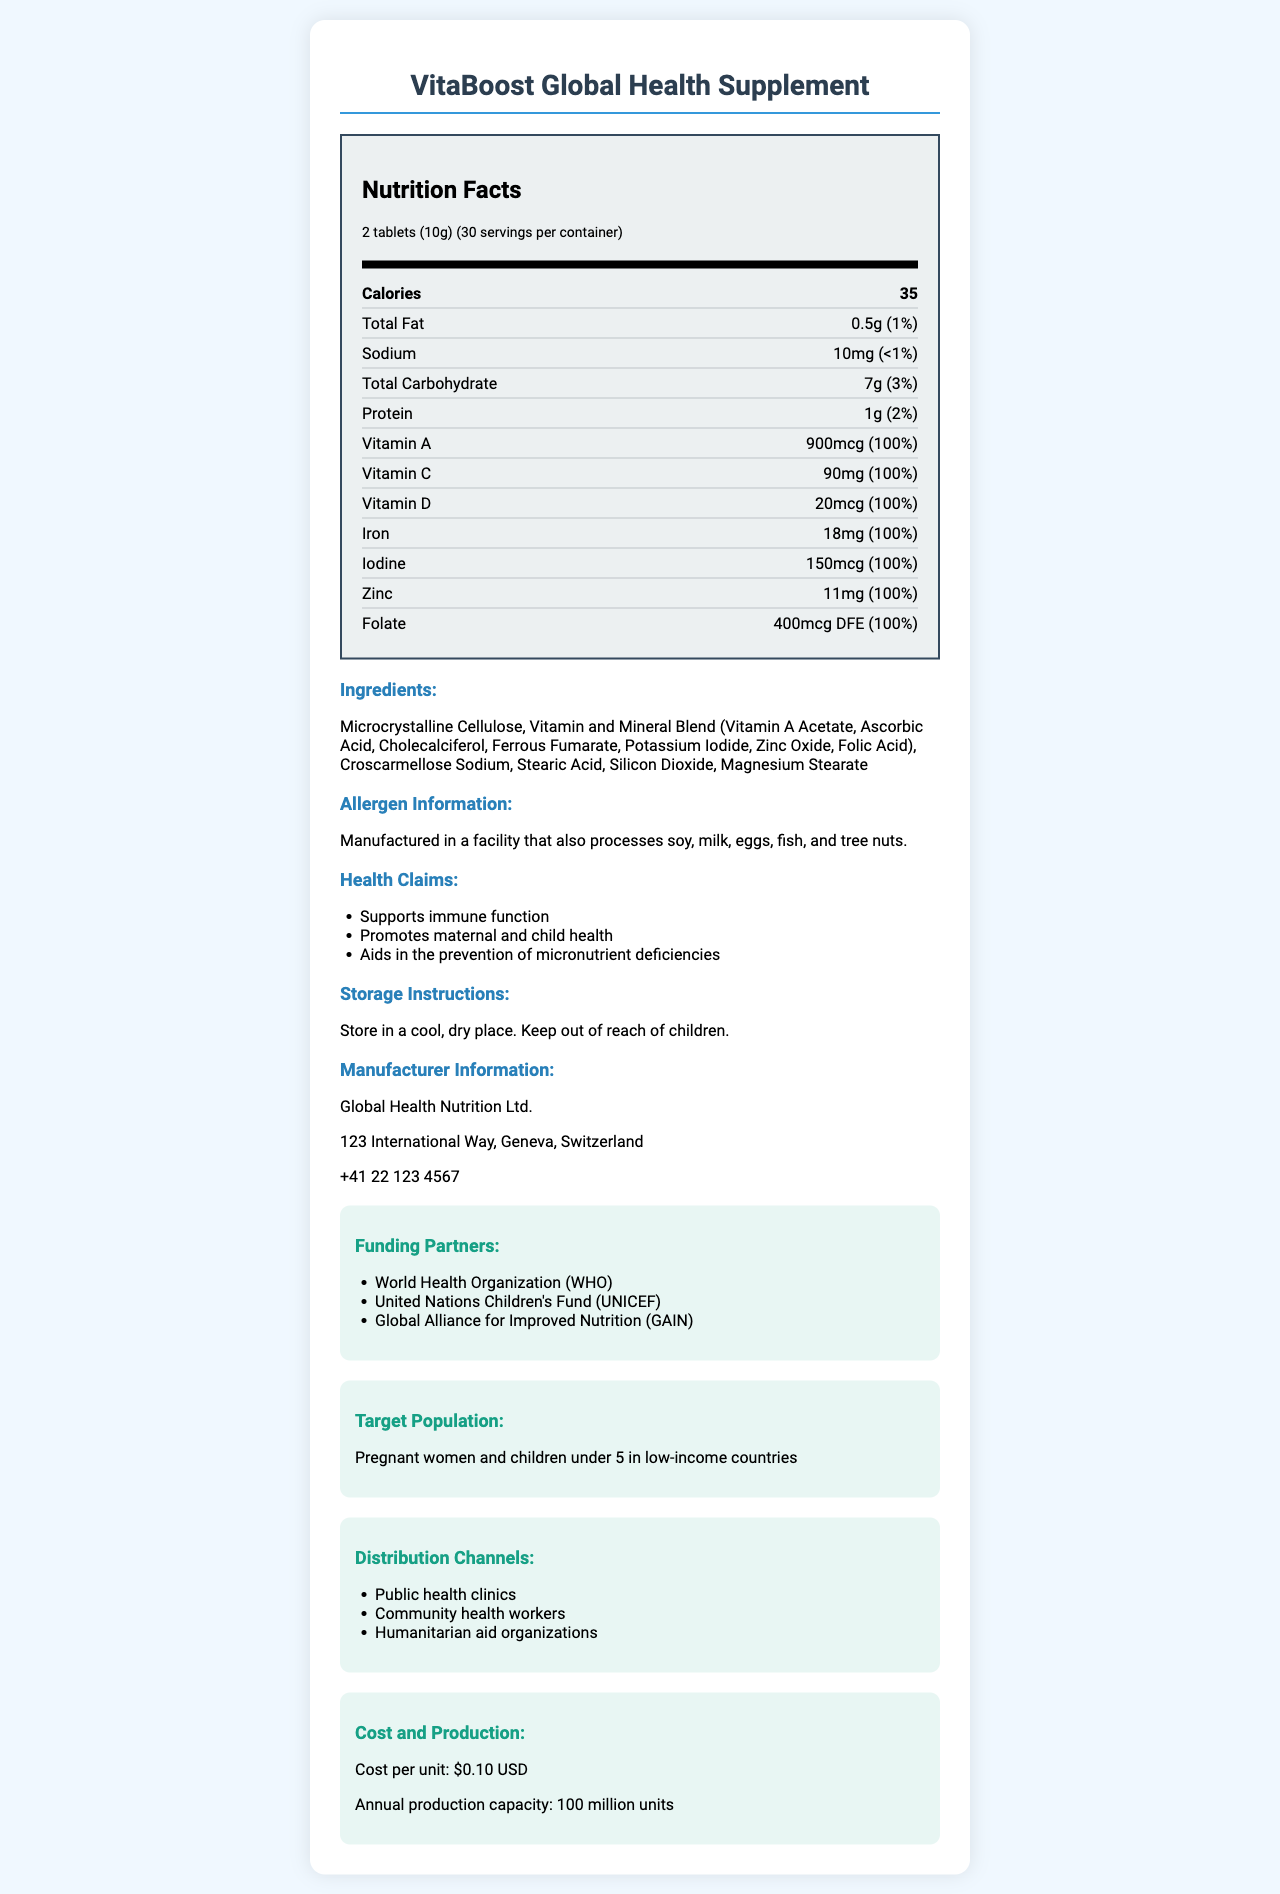what is the product name? The product name is clearly stated at the beginning of the document under the header.
Answer: VitaBoost Global Health Supplement What is the serving size? The serving size is listed right under the product name in the Nutrition Facts section.
Answer: 2 tablets (10g) What is the cost per unit? The cost per unit is found in the "Cost and Production" section of the document.
Answer: $0.10 USD Name two health benefits of the supplement. The health benefits are listed under the "Health Claims" section.
Answer: Supports immune function, Promotes maternal and child health What is the annual production capacity of this supplement? The production capacity is provided in the "Cost and Production" section.
Answer: 100 million units How many calories are in a serving of VitaBoost Global Health Supplement? The calories per serving is listed under the "Nutrition Facts" section.
Answer: 35 calories Which of the following nutrients has the highest daily value percentage in the supplement? A. Sodium B. Vitamin C C. Protein D. Total Carbohydrate Vitamin C has a daily value of 100%, which is the highest among the nutrients listed.
Answer: B. Vitamin C Which organization is not a funding partner for this product? A. World Health Organization (WHO) B. United Nations Children's Fund (UNICEF) C. International Red Cross D. Global Alliance for Improved Nutrition (GAIN) The International Red Cross is not listed among the funding partners; the partners listed are WHO, UNICEF, and GAIN.
Answer: C. International Red Cross Is this product manufactured in a facility that processes allergens? The allergen information states that the product is manufactured in a facility that also processes soy, milk, eggs, fish, and tree nuts.
Answer: Yes Summarize the main purpose of the VitaBoost Global Health Supplement. This summary captures the key points about the product's purpose, target population, health benefits, and distribution channels mentioned in the document.
Answer: The main purpose of the VitaBoost Global Health Supplement is to address specific health challenges in underserved communities by providing a blend of essential vitamins and minerals. It supports immune function, promotes maternal and child health, and aids in the prevention of micronutrient deficiencies. The product is targeted at pregnant women and children under 5 in low-income countries and is distributed through public health clinics, community health workers, and humanitarian aid organizations. What is the manufacturer's address? The manufacturer's address is listed in the "Manufacturer Information" section.
Answer: 123 International Way, Geneva, Switzerland What are the ingredients used in the supplement? The ingredients are listed in the "Ingredients" section of the document.
Answer: Microcrystalline Cellulose, Vitamin and Mineral Blend (Vitamin A Acetate, Ascorbic Acid, Cholecalciferol, Ferrous Fumarate, Potassium Iodide, Zinc Oxide, Folic Acid), Croscarmellose Sodium, Stearic Acid, Silicon Dioxide, Magnesium Stearate Does this supplement contain any dietary fiber? There is no mention of dietary fiber in the Nutrition Facts section.
Answer: No What is the amount of Iron in one serving of the supplement? The amount of Iron per serving is listed under the "Nutrition Facts" section.
Answer: 18mg What benefits does this product have for health? The health benefits are outlined in the "Health Claims" section.
Answer: Supports immune function, Promotes maternal and child health, Aids in the prevention of micronutrient deficiencies How many servings are there in one container of this supplement? The number of servings per container is mentioned in the "Nutrition Facts" section.
Answer: 30 servings What does "DFE" stand for in the context of folate's daily value? The document does not provide the meaning of "DFE," so this information cannot be determined from the visual information provided.
Answer: Cannot be determined Who is the target population for this supplement? The target population is specified in the "Target Population" section.
Answer: Pregnant women and children under 5 in low-income countries What is the recommended storage instruction for this supplement? The storage instructions are clearly stated in the "Storage Instructions" section.
Answer: Store in a cool, dry place. Keep out of reach of children. 